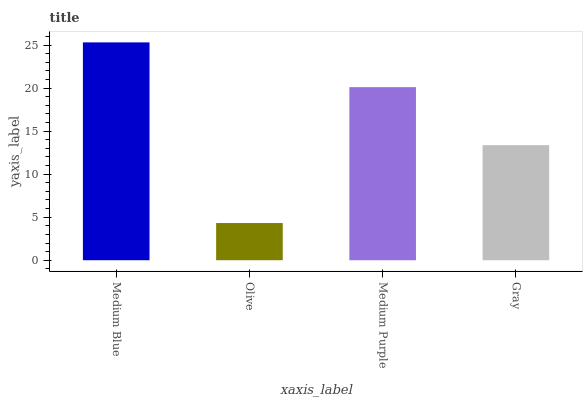Is Olive the minimum?
Answer yes or no. Yes. Is Medium Blue the maximum?
Answer yes or no. Yes. Is Medium Purple the minimum?
Answer yes or no. No. Is Medium Purple the maximum?
Answer yes or no. No. Is Medium Purple greater than Olive?
Answer yes or no. Yes. Is Olive less than Medium Purple?
Answer yes or no. Yes. Is Olive greater than Medium Purple?
Answer yes or no. No. Is Medium Purple less than Olive?
Answer yes or no. No. Is Medium Purple the high median?
Answer yes or no. Yes. Is Gray the low median?
Answer yes or no. Yes. Is Medium Blue the high median?
Answer yes or no. No. Is Medium Purple the low median?
Answer yes or no. No. 